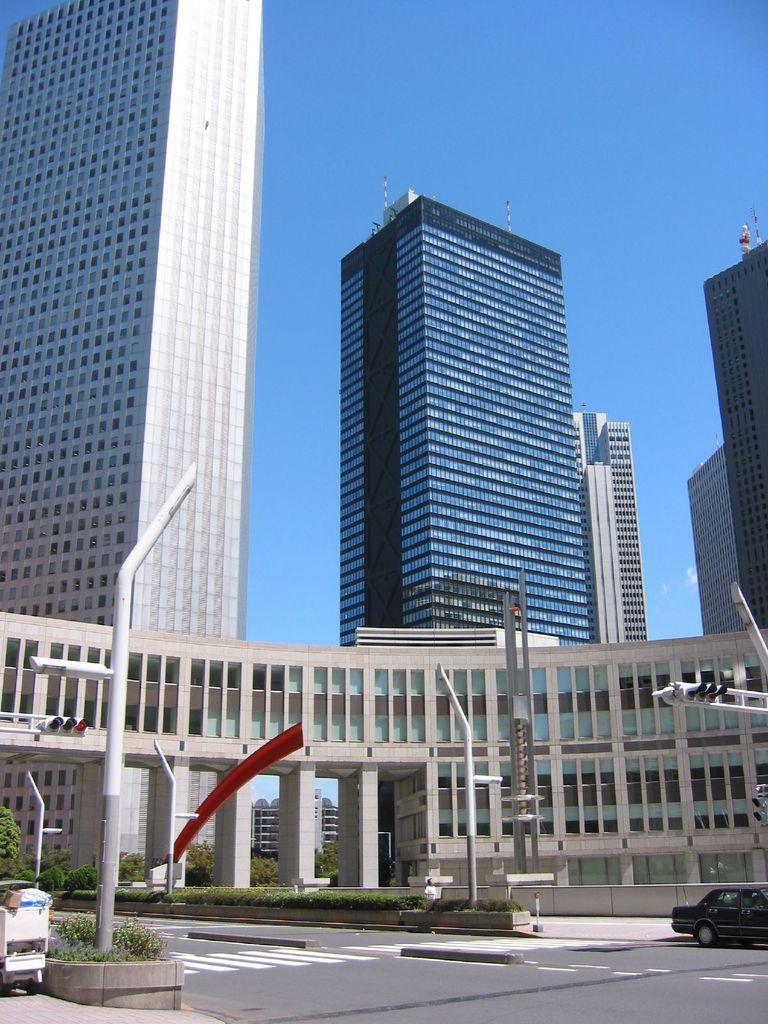How would you summarize this image in a sentence or two? In the picture we can see the road, near it we can see some poles, buildings and the sky. 